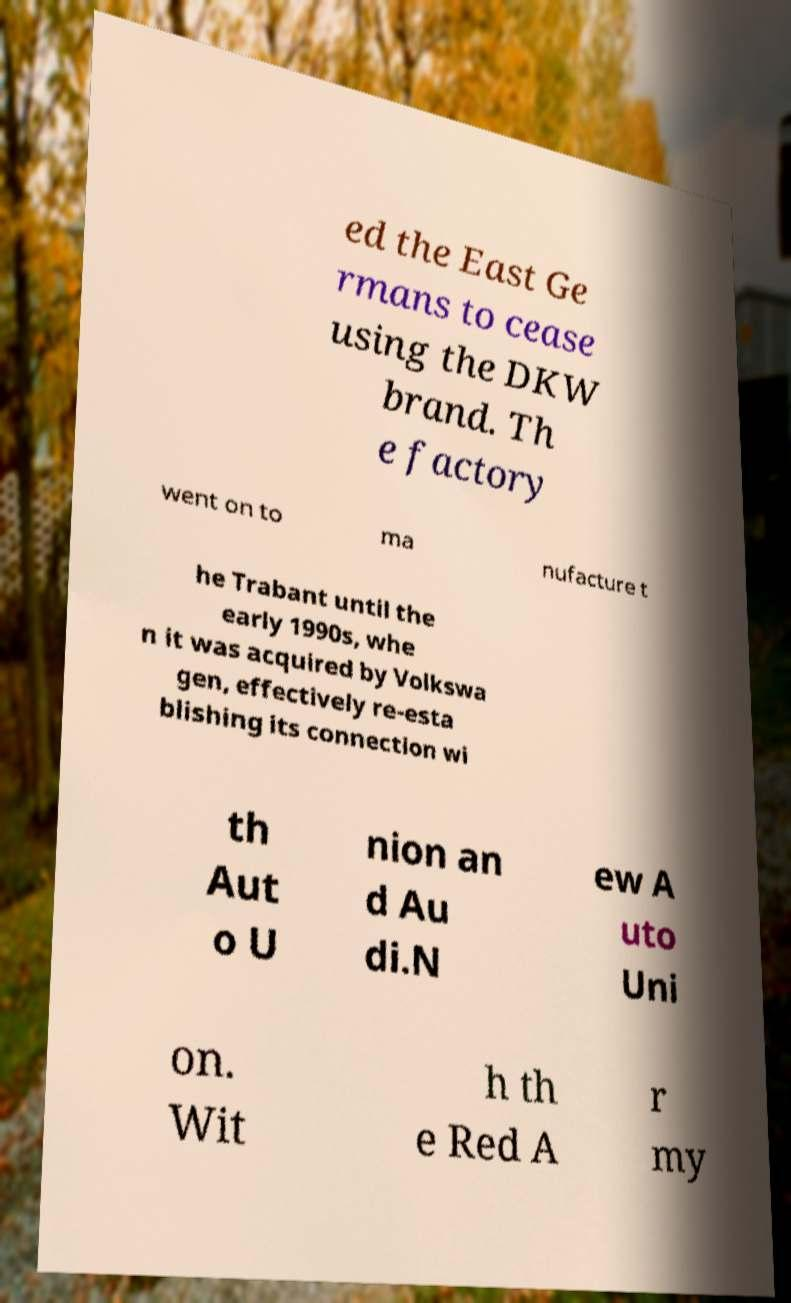What messages or text are displayed in this image? I need them in a readable, typed format. ed the East Ge rmans to cease using the DKW brand. Th e factory went on to ma nufacture t he Trabant until the early 1990s, whe n it was acquired by Volkswa gen, effectively re-esta blishing its connection wi th Aut o U nion an d Au di.N ew A uto Uni on. Wit h th e Red A r my 